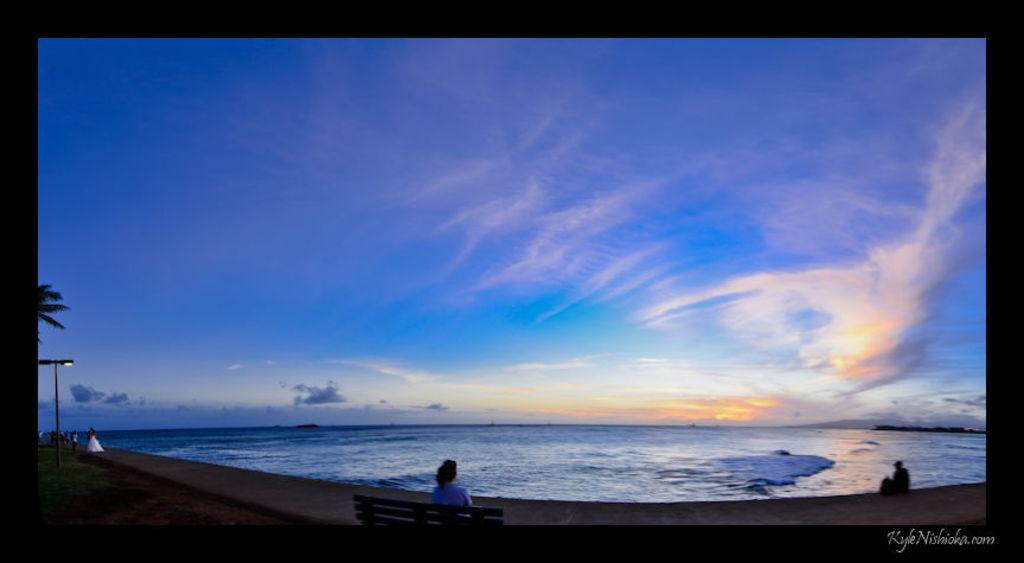<image>
Present a compact description of the photo's key features. A photo of a person on a bench says Kyle on the bottom. 